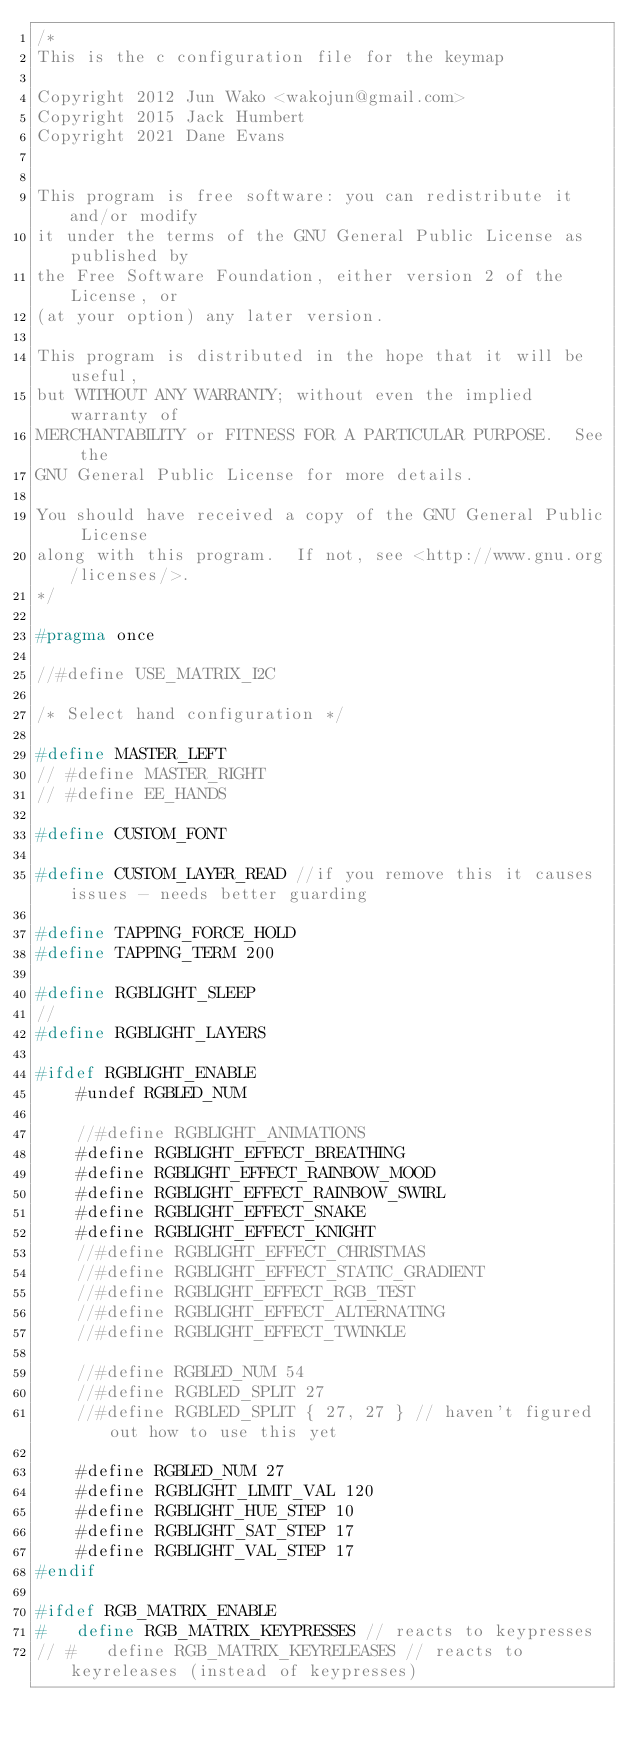Convert code to text. <code><loc_0><loc_0><loc_500><loc_500><_C_>/*
This is the c configuration file for the keymap

Copyright 2012 Jun Wako <wakojun@gmail.com>
Copyright 2015 Jack Humbert
Copyright 2021 Dane Evans


This program is free software: you can redistribute it and/or modify
it under the terms of the GNU General Public License as published by
the Free Software Foundation, either version 2 of the License, or
(at your option) any later version.

This program is distributed in the hope that it will be useful,
but WITHOUT ANY WARRANTY; without even the implied warranty of
MERCHANTABILITY or FITNESS FOR A PARTICULAR PURPOSE.  See the
GNU General Public License for more details.

You should have received a copy of the GNU General Public License
along with this program.  If not, see <http://www.gnu.org/licenses/>.
*/

#pragma once

//#define USE_MATRIX_I2C

/* Select hand configuration */

#define MASTER_LEFT
// #define MASTER_RIGHT
// #define EE_HANDS

#define CUSTOM_FONT

#define CUSTOM_LAYER_READ //if you remove this it causes issues - needs better guarding 

#define TAPPING_FORCE_HOLD
#define TAPPING_TERM 200

#define RGBLIGHT_SLEEP
//
#define RGBLIGHT_LAYERS

#ifdef RGBLIGHT_ENABLE
    #undef RGBLED_NUM
	
    //#define RGBLIGHT_ANIMATIONS
	#define RGBLIGHT_EFFECT_BREATHING
	#define RGBLIGHT_EFFECT_RAINBOW_MOOD
	#define RGBLIGHT_EFFECT_RAINBOW_SWIRL
	#define RGBLIGHT_EFFECT_SNAKE
	#define RGBLIGHT_EFFECT_KNIGHT
	//#define RGBLIGHT_EFFECT_CHRISTMAS
	//#define RGBLIGHT_EFFECT_STATIC_GRADIENT
	//#define RGBLIGHT_EFFECT_RGB_TEST
	//#define RGBLIGHT_EFFECT_ALTERNATING
	//#define RGBLIGHT_EFFECT_TWINKLE
	
    //#define RGBLED_NUM 54
	//#define RGBLED_SPLIT 27
	//#define RGBLED_SPLIT { 27, 27 } // haven't figured out how to use this yet 
	
	#define RGBLED_NUM 27
    #define RGBLIGHT_LIMIT_VAL 120
    #define RGBLIGHT_HUE_STEP 10
    #define RGBLIGHT_SAT_STEP 17
    #define RGBLIGHT_VAL_STEP 17
#endif

#ifdef RGB_MATRIX_ENABLE
#   define RGB_MATRIX_KEYPRESSES // reacts to keypresses
// #   define RGB_MATRIX_KEYRELEASES // reacts to keyreleases (instead of keypresses)</code> 